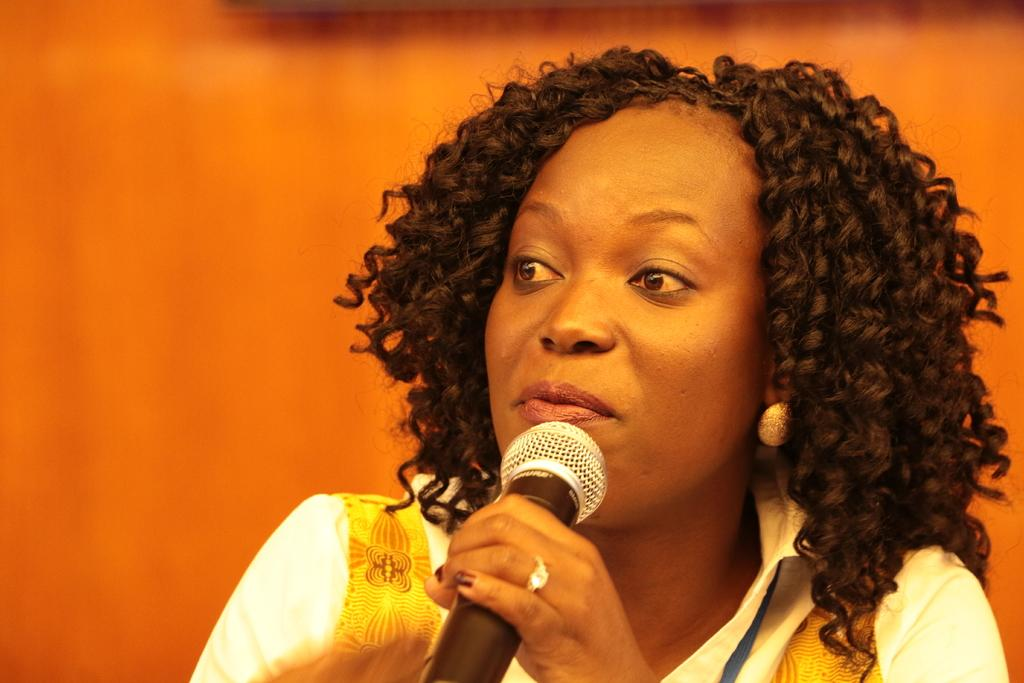Who is the main subject in the image? There is a woman in the image. What is the woman holding in her hand? The woman is holding a microphone in her hand. What color is the dress the woman is wearing? The woman is wearing a white color dress. How many children are playing with bubbles in the square in the image? There are no children, bubbles, or squares present in the image. 